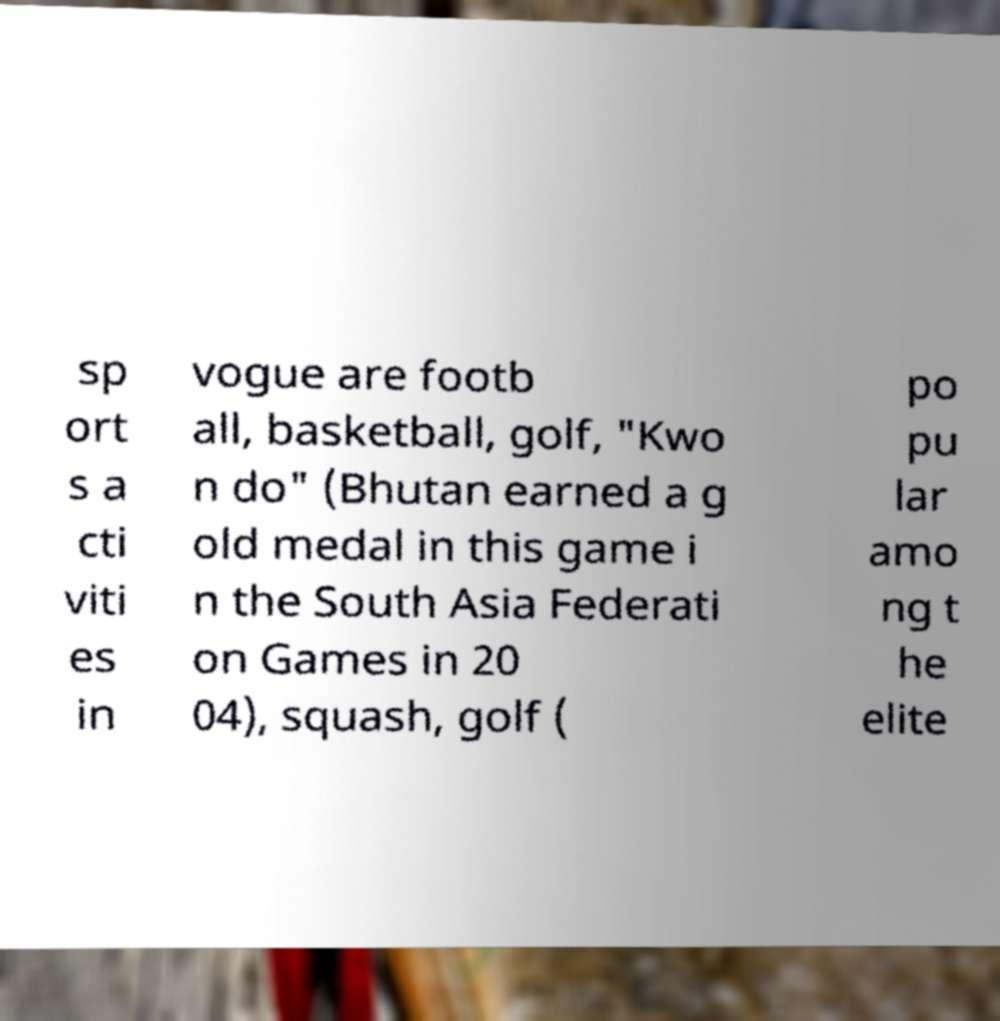Please read and relay the text visible in this image. What does it say? sp ort s a cti viti es in vogue are footb all, basketball, golf, "Kwo n do" (Bhutan earned a g old medal in this game i n the South Asia Federati on Games in 20 04), squash, golf ( po pu lar amo ng t he elite 